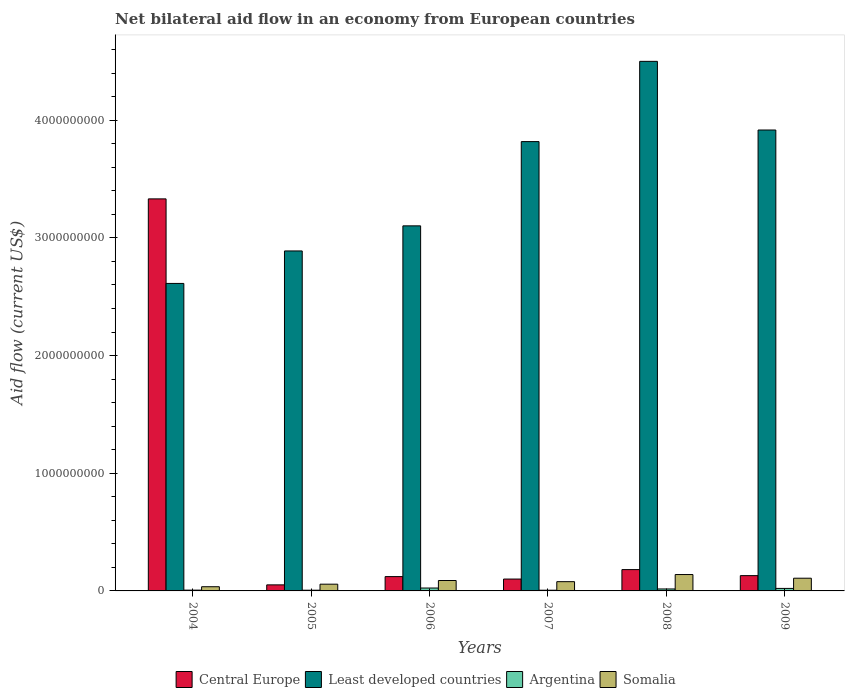How many different coloured bars are there?
Your response must be concise. 4. How many groups of bars are there?
Your answer should be very brief. 6. Are the number of bars on each tick of the X-axis equal?
Give a very brief answer. Yes. In how many cases, is the number of bars for a given year not equal to the number of legend labels?
Provide a succinct answer. 0. What is the net bilateral aid flow in Least developed countries in 2007?
Make the answer very short. 3.82e+09. Across all years, what is the maximum net bilateral aid flow in Least developed countries?
Your answer should be very brief. 4.50e+09. Across all years, what is the minimum net bilateral aid flow in Least developed countries?
Give a very brief answer. 2.61e+09. In which year was the net bilateral aid flow in Somalia maximum?
Ensure brevity in your answer.  2008. In which year was the net bilateral aid flow in Central Europe minimum?
Your answer should be very brief. 2005. What is the total net bilateral aid flow in Central Europe in the graph?
Ensure brevity in your answer.  3.92e+09. What is the difference between the net bilateral aid flow in Argentina in 2005 and that in 2009?
Provide a succinct answer. -1.52e+07. What is the difference between the net bilateral aid flow in Somalia in 2009 and the net bilateral aid flow in Least developed countries in 2006?
Provide a succinct answer. -2.99e+09. What is the average net bilateral aid flow in Central Europe per year?
Your answer should be very brief. 6.53e+08. In the year 2006, what is the difference between the net bilateral aid flow in Argentina and net bilateral aid flow in Central Europe?
Your response must be concise. -9.71e+07. What is the ratio of the net bilateral aid flow in Somalia in 2007 to that in 2008?
Ensure brevity in your answer.  0.56. What is the difference between the highest and the second highest net bilateral aid flow in Somalia?
Your response must be concise. 3.13e+07. What is the difference between the highest and the lowest net bilateral aid flow in Somalia?
Your response must be concise. 1.04e+08. Is it the case that in every year, the sum of the net bilateral aid flow in Somalia and net bilateral aid flow in Central Europe is greater than the sum of net bilateral aid flow in Argentina and net bilateral aid flow in Least developed countries?
Give a very brief answer. No. What does the 2nd bar from the left in 2004 represents?
Ensure brevity in your answer.  Least developed countries. What does the 3rd bar from the right in 2008 represents?
Provide a short and direct response. Least developed countries. Are all the bars in the graph horizontal?
Your answer should be compact. No. What is the difference between two consecutive major ticks on the Y-axis?
Provide a succinct answer. 1.00e+09. Are the values on the major ticks of Y-axis written in scientific E-notation?
Make the answer very short. No. Where does the legend appear in the graph?
Offer a very short reply. Bottom center. What is the title of the graph?
Your answer should be compact. Net bilateral aid flow in an economy from European countries. What is the label or title of the Y-axis?
Make the answer very short. Aid flow (current US$). What is the Aid flow (current US$) of Central Europe in 2004?
Keep it short and to the point. 3.33e+09. What is the Aid flow (current US$) of Least developed countries in 2004?
Your response must be concise. 2.61e+09. What is the Aid flow (current US$) of Argentina in 2004?
Provide a short and direct response. 6.68e+06. What is the Aid flow (current US$) in Somalia in 2004?
Make the answer very short. 3.57e+07. What is the Aid flow (current US$) of Central Europe in 2005?
Provide a short and direct response. 5.14e+07. What is the Aid flow (current US$) in Least developed countries in 2005?
Your answer should be very brief. 2.89e+09. What is the Aid flow (current US$) in Argentina in 2005?
Give a very brief answer. 6.03e+06. What is the Aid flow (current US$) in Somalia in 2005?
Your answer should be compact. 5.73e+07. What is the Aid flow (current US$) in Central Europe in 2006?
Keep it short and to the point. 1.22e+08. What is the Aid flow (current US$) of Least developed countries in 2006?
Keep it short and to the point. 3.10e+09. What is the Aid flow (current US$) of Argentina in 2006?
Your response must be concise. 2.46e+07. What is the Aid flow (current US$) of Somalia in 2006?
Offer a terse response. 8.85e+07. What is the Aid flow (current US$) in Central Europe in 2007?
Offer a terse response. 1.01e+08. What is the Aid flow (current US$) of Least developed countries in 2007?
Provide a short and direct response. 3.82e+09. What is the Aid flow (current US$) of Argentina in 2007?
Offer a very short reply. 6.10e+06. What is the Aid flow (current US$) of Somalia in 2007?
Make the answer very short. 7.86e+07. What is the Aid flow (current US$) of Central Europe in 2008?
Give a very brief answer. 1.81e+08. What is the Aid flow (current US$) in Least developed countries in 2008?
Provide a short and direct response. 4.50e+09. What is the Aid flow (current US$) in Argentina in 2008?
Ensure brevity in your answer.  1.66e+07. What is the Aid flow (current US$) in Somalia in 2008?
Provide a succinct answer. 1.39e+08. What is the Aid flow (current US$) in Central Europe in 2009?
Provide a short and direct response. 1.30e+08. What is the Aid flow (current US$) of Least developed countries in 2009?
Provide a short and direct response. 3.92e+09. What is the Aid flow (current US$) of Argentina in 2009?
Give a very brief answer. 2.13e+07. What is the Aid flow (current US$) of Somalia in 2009?
Your answer should be compact. 1.08e+08. Across all years, what is the maximum Aid flow (current US$) of Central Europe?
Your response must be concise. 3.33e+09. Across all years, what is the maximum Aid flow (current US$) of Least developed countries?
Ensure brevity in your answer.  4.50e+09. Across all years, what is the maximum Aid flow (current US$) of Argentina?
Give a very brief answer. 2.46e+07. Across all years, what is the maximum Aid flow (current US$) in Somalia?
Provide a succinct answer. 1.39e+08. Across all years, what is the minimum Aid flow (current US$) in Central Europe?
Your response must be concise. 5.14e+07. Across all years, what is the minimum Aid flow (current US$) in Least developed countries?
Provide a short and direct response. 2.61e+09. Across all years, what is the minimum Aid flow (current US$) of Argentina?
Your answer should be very brief. 6.03e+06. Across all years, what is the minimum Aid flow (current US$) of Somalia?
Provide a short and direct response. 3.57e+07. What is the total Aid flow (current US$) in Central Europe in the graph?
Your answer should be very brief. 3.92e+09. What is the total Aid flow (current US$) of Least developed countries in the graph?
Your answer should be compact. 2.08e+1. What is the total Aid flow (current US$) in Argentina in the graph?
Provide a short and direct response. 8.13e+07. What is the total Aid flow (current US$) of Somalia in the graph?
Provide a succinct answer. 5.07e+08. What is the difference between the Aid flow (current US$) in Central Europe in 2004 and that in 2005?
Offer a terse response. 3.28e+09. What is the difference between the Aid flow (current US$) in Least developed countries in 2004 and that in 2005?
Your answer should be compact. -2.76e+08. What is the difference between the Aid flow (current US$) in Argentina in 2004 and that in 2005?
Provide a succinct answer. 6.50e+05. What is the difference between the Aid flow (current US$) in Somalia in 2004 and that in 2005?
Give a very brief answer. -2.16e+07. What is the difference between the Aid flow (current US$) of Central Europe in 2004 and that in 2006?
Give a very brief answer. 3.21e+09. What is the difference between the Aid flow (current US$) of Least developed countries in 2004 and that in 2006?
Offer a very short reply. -4.89e+08. What is the difference between the Aid flow (current US$) in Argentina in 2004 and that in 2006?
Provide a succinct answer. -1.79e+07. What is the difference between the Aid flow (current US$) of Somalia in 2004 and that in 2006?
Make the answer very short. -5.28e+07. What is the difference between the Aid flow (current US$) of Central Europe in 2004 and that in 2007?
Provide a short and direct response. 3.23e+09. What is the difference between the Aid flow (current US$) of Least developed countries in 2004 and that in 2007?
Your answer should be compact. -1.21e+09. What is the difference between the Aid flow (current US$) of Argentina in 2004 and that in 2007?
Provide a short and direct response. 5.80e+05. What is the difference between the Aid flow (current US$) of Somalia in 2004 and that in 2007?
Your answer should be compact. -4.29e+07. What is the difference between the Aid flow (current US$) of Central Europe in 2004 and that in 2008?
Keep it short and to the point. 3.15e+09. What is the difference between the Aid flow (current US$) in Least developed countries in 2004 and that in 2008?
Offer a terse response. -1.89e+09. What is the difference between the Aid flow (current US$) of Argentina in 2004 and that in 2008?
Offer a very short reply. -9.93e+06. What is the difference between the Aid flow (current US$) in Somalia in 2004 and that in 2008?
Offer a very short reply. -1.04e+08. What is the difference between the Aid flow (current US$) of Central Europe in 2004 and that in 2009?
Ensure brevity in your answer.  3.20e+09. What is the difference between the Aid flow (current US$) in Least developed countries in 2004 and that in 2009?
Offer a terse response. -1.30e+09. What is the difference between the Aid flow (current US$) of Argentina in 2004 and that in 2009?
Ensure brevity in your answer.  -1.46e+07. What is the difference between the Aid flow (current US$) of Somalia in 2004 and that in 2009?
Your answer should be compact. -7.23e+07. What is the difference between the Aid flow (current US$) in Central Europe in 2005 and that in 2006?
Ensure brevity in your answer.  -7.03e+07. What is the difference between the Aid flow (current US$) of Least developed countries in 2005 and that in 2006?
Your response must be concise. -2.13e+08. What is the difference between the Aid flow (current US$) in Argentina in 2005 and that in 2006?
Your answer should be very brief. -1.86e+07. What is the difference between the Aid flow (current US$) of Somalia in 2005 and that in 2006?
Your answer should be very brief. -3.12e+07. What is the difference between the Aid flow (current US$) of Central Europe in 2005 and that in 2007?
Keep it short and to the point. -4.95e+07. What is the difference between the Aid flow (current US$) in Least developed countries in 2005 and that in 2007?
Ensure brevity in your answer.  -9.29e+08. What is the difference between the Aid flow (current US$) of Argentina in 2005 and that in 2007?
Provide a succinct answer. -7.00e+04. What is the difference between the Aid flow (current US$) of Somalia in 2005 and that in 2007?
Offer a very short reply. -2.13e+07. What is the difference between the Aid flow (current US$) in Central Europe in 2005 and that in 2008?
Your answer should be very brief. -1.30e+08. What is the difference between the Aid flow (current US$) in Least developed countries in 2005 and that in 2008?
Ensure brevity in your answer.  -1.61e+09. What is the difference between the Aid flow (current US$) in Argentina in 2005 and that in 2008?
Ensure brevity in your answer.  -1.06e+07. What is the difference between the Aid flow (current US$) in Somalia in 2005 and that in 2008?
Your response must be concise. -8.20e+07. What is the difference between the Aid flow (current US$) of Central Europe in 2005 and that in 2009?
Your answer should be compact. -7.85e+07. What is the difference between the Aid flow (current US$) of Least developed countries in 2005 and that in 2009?
Offer a terse response. -1.03e+09. What is the difference between the Aid flow (current US$) of Argentina in 2005 and that in 2009?
Offer a very short reply. -1.52e+07. What is the difference between the Aid flow (current US$) of Somalia in 2005 and that in 2009?
Offer a very short reply. -5.07e+07. What is the difference between the Aid flow (current US$) in Central Europe in 2006 and that in 2007?
Your answer should be compact. 2.08e+07. What is the difference between the Aid flow (current US$) of Least developed countries in 2006 and that in 2007?
Provide a short and direct response. -7.16e+08. What is the difference between the Aid flow (current US$) in Argentina in 2006 and that in 2007?
Your answer should be compact. 1.85e+07. What is the difference between the Aid flow (current US$) of Somalia in 2006 and that in 2007?
Offer a very short reply. 9.92e+06. What is the difference between the Aid flow (current US$) of Central Europe in 2006 and that in 2008?
Your answer should be compact. -5.94e+07. What is the difference between the Aid flow (current US$) in Least developed countries in 2006 and that in 2008?
Ensure brevity in your answer.  -1.40e+09. What is the difference between the Aid flow (current US$) of Argentina in 2006 and that in 2008?
Provide a short and direct response. 7.97e+06. What is the difference between the Aid flow (current US$) in Somalia in 2006 and that in 2008?
Your answer should be very brief. -5.07e+07. What is the difference between the Aid flow (current US$) of Central Europe in 2006 and that in 2009?
Provide a succinct answer. -8.24e+06. What is the difference between the Aid flow (current US$) of Least developed countries in 2006 and that in 2009?
Your answer should be compact. -8.14e+08. What is the difference between the Aid flow (current US$) of Argentina in 2006 and that in 2009?
Keep it short and to the point. 3.30e+06. What is the difference between the Aid flow (current US$) of Somalia in 2006 and that in 2009?
Provide a short and direct response. -1.95e+07. What is the difference between the Aid flow (current US$) of Central Europe in 2007 and that in 2008?
Your answer should be compact. -8.03e+07. What is the difference between the Aid flow (current US$) in Least developed countries in 2007 and that in 2008?
Give a very brief answer. -6.82e+08. What is the difference between the Aid flow (current US$) in Argentina in 2007 and that in 2008?
Your answer should be very brief. -1.05e+07. What is the difference between the Aid flow (current US$) of Somalia in 2007 and that in 2008?
Offer a very short reply. -6.06e+07. What is the difference between the Aid flow (current US$) in Central Europe in 2007 and that in 2009?
Keep it short and to the point. -2.91e+07. What is the difference between the Aid flow (current US$) in Least developed countries in 2007 and that in 2009?
Your answer should be compact. -9.84e+07. What is the difference between the Aid flow (current US$) in Argentina in 2007 and that in 2009?
Offer a terse response. -1.52e+07. What is the difference between the Aid flow (current US$) in Somalia in 2007 and that in 2009?
Your answer should be very brief. -2.94e+07. What is the difference between the Aid flow (current US$) in Central Europe in 2008 and that in 2009?
Offer a terse response. 5.12e+07. What is the difference between the Aid flow (current US$) in Least developed countries in 2008 and that in 2009?
Ensure brevity in your answer.  5.83e+08. What is the difference between the Aid flow (current US$) in Argentina in 2008 and that in 2009?
Give a very brief answer. -4.67e+06. What is the difference between the Aid flow (current US$) of Somalia in 2008 and that in 2009?
Provide a succinct answer. 3.13e+07. What is the difference between the Aid flow (current US$) in Central Europe in 2004 and the Aid flow (current US$) in Least developed countries in 2005?
Ensure brevity in your answer.  4.42e+08. What is the difference between the Aid flow (current US$) of Central Europe in 2004 and the Aid flow (current US$) of Argentina in 2005?
Provide a short and direct response. 3.33e+09. What is the difference between the Aid flow (current US$) of Central Europe in 2004 and the Aid flow (current US$) of Somalia in 2005?
Offer a very short reply. 3.27e+09. What is the difference between the Aid flow (current US$) of Least developed countries in 2004 and the Aid flow (current US$) of Argentina in 2005?
Your response must be concise. 2.61e+09. What is the difference between the Aid flow (current US$) in Least developed countries in 2004 and the Aid flow (current US$) in Somalia in 2005?
Make the answer very short. 2.56e+09. What is the difference between the Aid flow (current US$) of Argentina in 2004 and the Aid flow (current US$) of Somalia in 2005?
Keep it short and to the point. -5.06e+07. What is the difference between the Aid flow (current US$) in Central Europe in 2004 and the Aid flow (current US$) in Least developed countries in 2006?
Your response must be concise. 2.29e+08. What is the difference between the Aid flow (current US$) of Central Europe in 2004 and the Aid flow (current US$) of Argentina in 2006?
Offer a terse response. 3.31e+09. What is the difference between the Aid flow (current US$) in Central Europe in 2004 and the Aid flow (current US$) in Somalia in 2006?
Give a very brief answer. 3.24e+09. What is the difference between the Aid flow (current US$) of Least developed countries in 2004 and the Aid flow (current US$) of Argentina in 2006?
Keep it short and to the point. 2.59e+09. What is the difference between the Aid flow (current US$) in Least developed countries in 2004 and the Aid flow (current US$) in Somalia in 2006?
Provide a short and direct response. 2.52e+09. What is the difference between the Aid flow (current US$) of Argentina in 2004 and the Aid flow (current US$) of Somalia in 2006?
Your response must be concise. -8.19e+07. What is the difference between the Aid flow (current US$) of Central Europe in 2004 and the Aid flow (current US$) of Least developed countries in 2007?
Provide a short and direct response. -4.87e+08. What is the difference between the Aid flow (current US$) of Central Europe in 2004 and the Aid flow (current US$) of Argentina in 2007?
Your answer should be compact. 3.33e+09. What is the difference between the Aid flow (current US$) in Central Europe in 2004 and the Aid flow (current US$) in Somalia in 2007?
Keep it short and to the point. 3.25e+09. What is the difference between the Aid flow (current US$) of Least developed countries in 2004 and the Aid flow (current US$) of Argentina in 2007?
Offer a very short reply. 2.61e+09. What is the difference between the Aid flow (current US$) in Least developed countries in 2004 and the Aid flow (current US$) in Somalia in 2007?
Provide a short and direct response. 2.53e+09. What is the difference between the Aid flow (current US$) of Argentina in 2004 and the Aid flow (current US$) of Somalia in 2007?
Your answer should be compact. -7.19e+07. What is the difference between the Aid flow (current US$) in Central Europe in 2004 and the Aid flow (current US$) in Least developed countries in 2008?
Make the answer very short. -1.17e+09. What is the difference between the Aid flow (current US$) in Central Europe in 2004 and the Aid flow (current US$) in Argentina in 2008?
Give a very brief answer. 3.31e+09. What is the difference between the Aid flow (current US$) in Central Europe in 2004 and the Aid flow (current US$) in Somalia in 2008?
Ensure brevity in your answer.  3.19e+09. What is the difference between the Aid flow (current US$) in Least developed countries in 2004 and the Aid flow (current US$) in Argentina in 2008?
Offer a terse response. 2.60e+09. What is the difference between the Aid flow (current US$) in Least developed countries in 2004 and the Aid flow (current US$) in Somalia in 2008?
Your answer should be very brief. 2.47e+09. What is the difference between the Aid flow (current US$) in Argentina in 2004 and the Aid flow (current US$) in Somalia in 2008?
Your answer should be compact. -1.33e+08. What is the difference between the Aid flow (current US$) in Central Europe in 2004 and the Aid flow (current US$) in Least developed countries in 2009?
Offer a very short reply. -5.85e+08. What is the difference between the Aid flow (current US$) in Central Europe in 2004 and the Aid flow (current US$) in Argentina in 2009?
Your answer should be compact. 3.31e+09. What is the difference between the Aid flow (current US$) of Central Europe in 2004 and the Aid flow (current US$) of Somalia in 2009?
Offer a very short reply. 3.22e+09. What is the difference between the Aid flow (current US$) in Least developed countries in 2004 and the Aid flow (current US$) in Argentina in 2009?
Make the answer very short. 2.59e+09. What is the difference between the Aid flow (current US$) in Least developed countries in 2004 and the Aid flow (current US$) in Somalia in 2009?
Your response must be concise. 2.50e+09. What is the difference between the Aid flow (current US$) in Argentina in 2004 and the Aid flow (current US$) in Somalia in 2009?
Provide a succinct answer. -1.01e+08. What is the difference between the Aid flow (current US$) in Central Europe in 2005 and the Aid flow (current US$) in Least developed countries in 2006?
Your answer should be very brief. -3.05e+09. What is the difference between the Aid flow (current US$) of Central Europe in 2005 and the Aid flow (current US$) of Argentina in 2006?
Your response must be concise. 2.68e+07. What is the difference between the Aid flow (current US$) of Central Europe in 2005 and the Aid flow (current US$) of Somalia in 2006?
Make the answer very short. -3.71e+07. What is the difference between the Aid flow (current US$) in Least developed countries in 2005 and the Aid flow (current US$) in Argentina in 2006?
Ensure brevity in your answer.  2.86e+09. What is the difference between the Aid flow (current US$) of Least developed countries in 2005 and the Aid flow (current US$) of Somalia in 2006?
Ensure brevity in your answer.  2.80e+09. What is the difference between the Aid flow (current US$) in Argentina in 2005 and the Aid flow (current US$) in Somalia in 2006?
Keep it short and to the point. -8.25e+07. What is the difference between the Aid flow (current US$) in Central Europe in 2005 and the Aid flow (current US$) in Least developed countries in 2007?
Ensure brevity in your answer.  -3.77e+09. What is the difference between the Aid flow (current US$) of Central Europe in 2005 and the Aid flow (current US$) of Argentina in 2007?
Offer a very short reply. 4.53e+07. What is the difference between the Aid flow (current US$) of Central Europe in 2005 and the Aid flow (current US$) of Somalia in 2007?
Your answer should be compact. -2.72e+07. What is the difference between the Aid flow (current US$) of Least developed countries in 2005 and the Aid flow (current US$) of Argentina in 2007?
Provide a succinct answer. 2.88e+09. What is the difference between the Aid flow (current US$) in Least developed countries in 2005 and the Aid flow (current US$) in Somalia in 2007?
Your answer should be very brief. 2.81e+09. What is the difference between the Aid flow (current US$) of Argentina in 2005 and the Aid flow (current US$) of Somalia in 2007?
Provide a short and direct response. -7.26e+07. What is the difference between the Aid flow (current US$) of Central Europe in 2005 and the Aid flow (current US$) of Least developed countries in 2008?
Give a very brief answer. -4.45e+09. What is the difference between the Aid flow (current US$) in Central Europe in 2005 and the Aid flow (current US$) in Argentina in 2008?
Offer a very short reply. 3.48e+07. What is the difference between the Aid flow (current US$) of Central Europe in 2005 and the Aid flow (current US$) of Somalia in 2008?
Offer a terse response. -8.78e+07. What is the difference between the Aid flow (current US$) of Least developed countries in 2005 and the Aid flow (current US$) of Argentina in 2008?
Your answer should be very brief. 2.87e+09. What is the difference between the Aid flow (current US$) of Least developed countries in 2005 and the Aid flow (current US$) of Somalia in 2008?
Offer a very short reply. 2.75e+09. What is the difference between the Aid flow (current US$) in Argentina in 2005 and the Aid flow (current US$) in Somalia in 2008?
Provide a succinct answer. -1.33e+08. What is the difference between the Aid flow (current US$) of Central Europe in 2005 and the Aid flow (current US$) of Least developed countries in 2009?
Your response must be concise. -3.87e+09. What is the difference between the Aid flow (current US$) of Central Europe in 2005 and the Aid flow (current US$) of Argentina in 2009?
Offer a terse response. 3.01e+07. What is the difference between the Aid flow (current US$) in Central Europe in 2005 and the Aid flow (current US$) in Somalia in 2009?
Offer a very short reply. -5.66e+07. What is the difference between the Aid flow (current US$) in Least developed countries in 2005 and the Aid flow (current US$) in Argentina in 2009?
Your answer should be very brief. 2.87e+09. What is the difference between the Aid flow (current US$) of Least developed countries in 2005 and the Aid flow (current US$) of Somalia in 2009?
Provide a short and direct response. 2.78e+09. What is the difference between the Aid flow (current US$) in Argentina in 2005 and the Aid flow (current US$) in Somalia in 2009?
Make the answer very short. -1.02e+08. What is the difference between the Aid flow (current US$) of Central Europe in 2006 and the Aid flow (current US$) of Least developed countries in 2007?
Make the answer very short. -3.70e+09. What is the difference between the Aid flow (current US$) of Central Europe in 2006 and the Aid flow (current US$) of Argentina in 2007?
Your answer should be compact. 1.16e+08. What is the difference between the Aid flow (current US$) in Central Europe in 2006 and the Aid flow (current US$) in Somalia in 2007?
Provide a succinct answer. 4.31e+07. What is the difference between the Aid flow (current US$) of Least developed countries in 2006 and the Aid flow (current US$) of Argentina in 2007?
Keep it short and to the point. 3.10e+09. What is the difference between the Aid flow (current US$) in Least developed countries in 2006 and the Aid flow (current US$) in Somalia in 2007?
Ensure brevity in your answer.  3.02e+09. What is the difference between the Aid flow (current US$) in Argentina in 2006 and the Aid flow (current US$) in Somalia in 2007?
Offer a very short reply. -5.40e+07. What is the difference between the Aid flow (current US$) of Central Europe in 2006 and the Aid flow (current US$) of Least developed countries in 2008?
Your answer should be very brief. -4.38e+09. What is the difference between the Aid flow (current US$) of Central Europe in 2006 and the Aid flow (current US$) of Argentina in 2008?
Provide a succinct answer. 1.05e+08. What is the difference between the Aid flow (current US$) of Central Europe in 2006 and the Aid flow (current US$) of Somalia in 2008?
Provide a short and direct response. -1.76e+07. What is the difference between the Aid flow (current US$) of Least developed countries in 2006 and the Aid flow (current US$) of Argentina in 2008?
Make the answer very short. 3.09e+09. What is the difference between the Aid flow (current US$) in Least developed countries in 2006 and the Aid flow (current US$) in Somalia in 2008?
Ensure brevity in your answer.  2.96e+09. What is the difference between the Aid flow (current US$) in Argentina in 2006 and the Aid flow (current US$) in Somalia in 2008?
Offer a very short reply. -1.15e+08. What is the difference between the Aid flow (current US$) in Central Europe in 2006 and the Aid flow (current US$) in Least developed countries in 2009?
Keep it short and to the point. -3.79e+09. What is the difference between the Aid flow (current US$) of Central Europe in 2006 and the Aid flow (current US$) of Argentina in 2009?
Make the answer very short. 1.00e+08. What is the difference between the Aid flow (current US$) in Central Europe in 2006 and the Aid flow (current US$) in Somalia in 2009?
Offer a very short reply. 1.37e+07. What is the difference between the Aid flow (current US$) in Least developed countries in 2006 and the Aid flow (current US$) in Argentina in 2009?
Your answer should be very brief. 3.08e+09. What is the difference between the Aid flow (current US$) in Least developed countries in 2006 and the Aid flow (current US$) in Somalia in 2009?
Your response must be concise. 2.99e+09. What is the difference between the Aid flow (current US$) of Argentina in 2006 and the Aid flow (current US$) of Somalia in 2009?
Keep it short and to the point. -8.34e+07. What is the difference between the Aid flow (current US$) in Central Europe in 2007 and the Aid flow (current US$) in Least developed countries in 2008?
Offer a very short reply. -4.40e+09. What is the difference between the Aid flow (current US$) of Central Europe in 2007 and the Aid flow (current US$) of Argentina in 2008?
Offer a very short reply. 8.43e+07. What is the difference between the Aid flow (current US$) of Central Europe in 2007 and the Aid flow (current US$) of Somalia in 2008?
Make the answer very short. -3.84e+07. What is the difference between the Aid flow (current US$) of Least developed countries in 2007 and the Aid flow (current US$) of Argentina in 2008?
Offer a very short reply. 3.80e+09. What is the difference between the Aid flow (current US$) of Least developed countries in 2007 and the Aid flow (current US$) of Somalia in 2008?
Your answer should be very brief. 3.68e+09. What is the difference between the Aid flow (current US$) in Argentina in 2007 and the Aid flow (current US$) in Somalia in 2008?
Make the answer very short. -1.33e+08. What is the difference between the Aid flow (current US$) of Central Europe in 2007 and the Aid flow (current US$) of Least developed countries in 2009?
Offer a terse response. -3.82e+09. What is the difference between the Aid flow (current US$) of Central Europe in 2007 and the Aid flow (current US$) of Argentina in 2009?
Provide a short and direct response. 7.96e+07. What is the difference between the Aid flow (current US$) in Central Europe in 2007 and the Aid flow (current US$) in Somalia in 2009?
Keep it short and to the point. -7.13e+06. What is the difference between the Aid flow (current US$) of Least developed countries in 2007 and the Aid flow (current US$) of Argentina in 2009?
Provide a succinct answer. 3.80e+09. What is the difference between the Aid flow (current US$) in Least developed countries in 2007 and the Aid flow (current US$) in Somalia in 2009?
Offer a very short reply. 3.71e+09. What is the difference between the Aid flow (current US$) of Argentina in 2007 and the Aid flow (current US$) of Somalia in 2009?
Offer a very short reply. -1.02e+08. What is the difference between the Aid flow (current US$) in Central Europe in 2008 and the Aid flow (current US$) in Least developed countries in 2009?
Make the answer very short. -3.74e+09. What is the difference between the Aid flow (current US$) of Central Europe in 2008 and the Aid flow (current US$) of Argentina in 2009?
Your answer should be compact. 1.60e+08. What is the difference between the Aid flow (current US$) of Central Europe in 2008 and the Aid flow (current US$) of Somalia in 2009?
Your answer should be compact. 7.31e+07. What is the difference between the Aid flow (current US$) of Least developed countries in 2008 and the Aid flow (current US$) of Argentina in 2009?
Ensure brevity in your answer.  4.48e+09. What is the difference between the Aid flow (current US$) of Least developed countries in 2008 and the Aid flow (current US$) of Somalia in 2009?
Provide a short and direct response. 4.39e+09. What is the difference between the Aid flow (current US$) of Argentina in 2008 and the Aid flow (current US$) of Somalia in 2009?
Your answer should be compact. -9.14e+07. What is the average Aid flow (current US$) in Central Europe per year?
Make the answer very short. 6.53e+08. What is the average Aid flow (current US$) of Least developed countries per year?
Offer a very short reply. 3.47e+09. What is the average Aid flow (current US$) of Argentina per year?
Your response must be concise. 1.35e+07. What is the average Aid flow (current US$) in Somalia per year?
Offer a very short reply. 8.46e+07. In the year 2004, what is the difference between the Aid flow (current US$) of Central Europe and Aid flow (current US$) of Least developed countries?
Keep it short and to the point. 7.18e+08. In the year 2004, what is the difference between the Aid flow (current US$) of Central Europe and Aid flow (current US$) of Argentina?
Offer a terse response. 3.32e+09. In the year 2004, what is the difference between the Aid flow (current US$) of Central Europe and Aid flow (current US$) of Somalia?
Your response must be concise. 3.30e+09. In the year 2004, what is the difference between the Aid flow (current US$) in Least developed countries and Aid flow (current US$) in Argentina?
Offer a terse response. 2.61e+09. In the year 2004, what is the difference between the Aid flow (current US$) of Least developed countries and Aid flow (current US$) of Somalia?
Your response must be concise. 2.58e+09. In the year 2004, what is the difference between the Aid flow (current US$) of Argentina and Aid flow (current US$) of Somalia?
Provide a short and direct response. -2.90e+07. In the year 2005, what is the difference between the Aid flow (current US$) of Central Europe and Aid flow (current US$) of Least developed countries?
Your answer should be compact. -2.84e+09. In the year 2005, what is the difference between the Aid flow (current US$) in Central Europe and Aid flow (current US$) in Argentina?
Make the answer very short. 4.54e+07. In the year 2005, what is the difference between the Aid flow (current US$) in Central Europe and Aid flow (current US$) in Somalia?
Make the answer very short. -5.88e+06. In the year 2005, what is the difference between the Aid flow (current US$) in Least developed countries and Aid flow (current US$) in Argentina?
Your answer should be very brief. 2.88e+09. In the year 2005, what is the difference between the Aid flow (current US$) of Least developed countries and Aid flow (current US$) of Somalia?
Your response must be concise. 2.83e+09. In the year 2005, what is the difference between the Aid flow (current US$) in Argentina and Aid flow (current US$) in Somalia?
Offer a terse response. -5.13e+07. In the year 2006, what is the difference between the Aid flow (current US$) in Central Europe and Aid flow (current US$) in Least developed countries?
Give a very brief answer. -2.98e+09. In the year 2006, what is the difference between the Aid flow (current US$) in Central Europe and Aid flow (current US$) in Argentina?
Keep it short and to the point. 9.71e+07. In the year 2006, what is the difference between the Aid flow (current US$) in Central Europe and Aid flow (current US$) in Somalia?
Give a very brief answer. 3.32e+07. In the year 2006, what is the difference between the Aid flow (current US$) of Least developed countries and Aid flow (current US$) of Argentina?
Your response must be concise. 3.08e+09. In the year 2006, what is the difference between the Aid flow (current US$) in Least developed countries and Aid flow (current US$) in Somalia?
Provide a succinct answer. 3.01e+09. In the year 2006, what is the difference between the Aid flow (current US$) in Argentina and Aid flow (current US$) in Somalia?
Your answer should be very brief. -6.40e+07. In the year 2007, what is the difference between the Aid flow (current US$) of Central Europe and Aid flow (current US$) of Least developed countries?
Keep it short and to the point. -3.72e+09. In the year 2007, what is the difference between the Aid flow (current US$) of Central Europe and Aid flow (current US$) of Argentina?
Provide a short and direct response. 9.48e+07. In the year 2007, what is the difference between the Aid flow (current US$) of Central Europe and Aid flow (current US$) of Somalia?
Provide a short and direct response. 2.22e+07. In the year 2007, what is the difference between the Aid flow (current US$) in Least developed countries and Aid flow (current US$) in Argentina?
Offer a terse response. 3.81e+09. In the year 2007, what is the difference between the Aid flow (current US$) in Least developed countries and Aid flow (current US$) in Somalia?
Ensure brevity in your answer.  3.74e+09. In the year 2007, what is the difference between the Aid flow (current US$) in Argentina and Aid flow (current US$) in Somalia?
Your response must be concise. -7.25e+07. In the year 2008, what is the difference between the Aid flow (current US$) of Central Europe and Aid flow (current US$) of Least developed countries?
Provide a succinct answer. -4.32e+09. In the year 2008, what is the difference between the Aid flow (current US$) in Central Europe and Aid flow (current US$) in Argentina?
Provide a short and direct response. 1.65e+08. In the year 2008, what is the difference between the Aid flow (current US$) in Central Europe and Aid flow (current US$) in Somalia?
Make the answer very short. 4.19e+07. In the year 2008, what is the difference between the Aid flow (current US$) in Least developed countries and Aid flow (current US$) in Argentina?
Provide a succinct answer. 4.48e+09. In the year 2008, what is the difference between the Aid flow (current US$) of Least developed countries and Aid flow (current US$) of Somalia?
Your response must be concise. 4.36e+09. In the year 2008, what is the difference between the Aid flow (current US$) in Argentina and Aid flow (current US$) in Somalia?
Your answer should be compact. -1.23e+08. In the year 2009, what is the difference between the Aid flow (current US$) in Central Europe and Aid flow (current US$) in Least developed countries?
Give a very brief answer. -3.79e+09. In the year 2009, what is the difference between the Aid flow (current US$) in Central Europe and Aid flow (current US$) in Argentina?
Offer a very short reply. 1.09e+08. In the year 2009, what is the difference between the Aid flow (current US$) in Central Europe and Aid flow (current US$) in Somalia?
Offer a very short reply. 2.19e+07. In the year 2009, what is the difference between the Aid flow (current US$) in Least developed countries and Aid flow (current US$) in Argentina?
Ensure brevity in your answer.  3.90e+09. In the year 2009, what is the difference between the Aid flow (current US$) of Least developed countries and Aid flow (current US$) of Somalia?
Offer a terse response. 3.81e+09. In the year 2009, what is the difference between the Aid flow (current US$) of Argentina and Aid flow (current US$) of Somalia?
Ensure brevity in your answer.  -8.67e+07. What is the ratio of the Aid flow (current US$) of Central Europe in 2004 to that in 2005?
Ensure brevity in your answer.  64.8. What is the ratio of the Aid flow (current US$) in Least developed countries in 2004 to that in 2005?
Your answer should be compact. 0.9. What is the ratio of the Aid flow (current US$) in Argentina in 2004 to that in 2005?
Make the answer very short. 1.11. What is the ratio of the Aid flow (current US$) of Somalia in 2004 to that in 2005?
Make the answer very short. 0.62. What is the ratio of the Aid flow (current US$) of Central Europe in 2004 to that in 2006?
Your answer should be very brief. 27.37. What is the ratio of the Aid flow (current US$) in Least developed countries in 2004 to that in 2006?
Make the answer very short. 0.84. What is the ratio of the Aid flow (current US$) of Argentina in 2004 to that in 2006?
Offer a terse response. 0.27. What is the ratio of the Aid flow (current US$) in Somalia in 2004 to that in 2006?
Provide a short and direct response. 0.4. What is the ratio of the Aid flow (current US$) in Central Europe in 2004 to that in 2007?
Ensure brevity in your answer.  33.03. What is the ratio of the Aid flow (current US$) in Least developed countries in 2004 to that in 2007?
Your answer should be very brief. 0.68. What is the ratio of the Aid flow (current US$) of Argentina in 2004 to that in 2007?
Keep it short and to the point. 1.1. What is the ratio of the Aid flow (current US$) in Somalia in 2004 to that in 2007?
Your response must be concise. 0.45. What is the ratio of the Aid flow (current US$) of Central Europe in 2004 to that in 2008?
Your answer should be compact. 18.39. What is the ratio of the Aid flow (current US$) of Least developed countries in 2004 to that in 2008?
Offer a terse response. 0.58. What is the ratio of the Aid flow (current US$) in Argentina in 2004 to that in 2008?
Ensure brevity in your answer.  0.4. What is the ratio of the Aid flow (current US$) of Somalia in 2004 to that in 2008?
Provide a succinct answer. 0.26. What is the ratio of the Aid flow (current US$) of Central Europe in 2004 to that in 2009?
Offer a terse response. 25.64. What is the ratio of the Aid flow (current US$) of Least developed countries in 2004 to that in 2009?
Your answer should be compact. 0.67. What is the ratio of the Aid flow (current US$) in Argentina in 2004 to that in 2009?
Your answer should be very brief. 0.31. What is the ratio of the Aid flow (current US$) of Somalia in 2004 to that in 2009?
Provide a succinct answer. 0.33. What is the ratio of the Aid flow (current US$) in Central Europe in 2005 to that in 2006?
Offer a very short reply. 0.42. What is the ratio of the Aid flow (current US$) in Least developed countries in 2005 to that in 2006?
Keep it short and to the point. 0.93. What is the ratio of the Aid flow (current US$) of Argentina in 2005 to that in 2006?
Provide a short and direct response. 0.25. What is the ratio of the Aid flow (current US$) of Somalia in 2005 to that in 2006?
Provide a succinct answer. 0.65. What is the ratio of the Aid flow (current US$) in Central Europe in 2005 to that in 2007?
Your response must be concise. 0.51. What is the ratio of the Aid flow (current US$) of Least developed countries in 2005 to that in 2007?
Keep it short and to the point. 0.76. What is the ratio of the Aid flow (current US$) of Argentina in 2005 to that in 2007?
Your answer should be compact. 0.99. What is the ratio of the Aid flow (current US$) of Somalia in 2005 to that in 2007?
Make the answer very short. 0.73. What is the ratio of the Aid flow (current US$) of Central Europe in 2005 to that in 2008?
Provide a succinct answer. 0.28. What is the ratio of the Aid flow (current US$) of Least developed countries in 2005 to that in 2008?
Provide a succinct answer. 0.64. What is the ratio of the Aid flow (current US$) in Argentina in 2005 to that in 2008?
Your answer should be compact. 0.36. What is the ratio of the Aid flow (current US$) in Somalia in 2005 to that in 2008?
Give a very brief answer. 0.41. What is the ratio of the Aid flow (current US$) of Central Europe in 2005 to that in 2009?
Make the answer very short. 0.4. What is the ratio of the Aid flow (current US$) of Least developed countries in 2005 to that in 2009?
Make the answer very short. 0.74. What is the ratio of the Aid flow (current US$) in Argentina in 2005 to that in 2009?
Your answer should be compact. 0.28. What is the ratio of the Aid flow (current US$) in Somalia in 2005 to that in 2009?
Provide a succinct answer. 0.53. What is the ratio of the Aid flow (current US$) of Central Europe in 2006 to that in 2007?
Make the answer very short. 1.21. What is the ratio of the Aid flow (current US$) in Least developed countries in 2006 to that in 2007?
Provide a short and direct response. 0.81. What is the ratio of the Aid flow (current US$) of Argentina in 2006 to that in 2007?
Ensure brevity in your answer.  4.03. What is the ratio of the Aid flow (current US$) of Somalia in 2006 to that in 2007?
Ensure brevity in your answer.  1.13. What is the ratio of the Aid flow (current US$) in Central Europe in 2006 to that in 2008?
Your answer should be very brief. 0.67. What is the ratio of the Aid flow (current US$) of Least developed countries in 2006 to that in 2008?
Offer a terse response. 0.69. What is the ratio of the Aid flow (current US$) in Argentina in 2006 to that in 2008?
Offer a very short reply. 1.48. What is the ratio of the Aid flow (current US$) of Somalia in 2006 to that in 2008?
Your response must be concise. 0.64. What is the ratio of the Aid flow (current US$) in Central Europe in 2006 to that in 2009?
Offer a very short reply. 0.94. What is the ratio of the Aid flow (current US$) in Least developed countries in 2006 to that in 2009?
Keep it short and to the point. 0.79. What is the ratio of the Aid flow (current US$) of Argentina in 2006 to that in 2009?
Give a very brief answer. 1.16. What is the ratio of the Aid flow (current US$) in Somalia in 2006 to that in 2009?
Offer a very short reply. 0.82. What is the ratio of the Aid flow (current US$) in Central Europe in 2007 to that in 2008?
Provide a succinct answer. 0.56. What is the ratio of the Aid flow (current US$) in Least developed countries in 2007 to that in 2008?
Your answer should be compact. 0.85. What is the ratio of the Aid flow (current US$) in Argentina in 2007 to that in 2008?
Offer a terse response. 0.37. What is the ratio of the Aid flow (current US$) in Somalia in 2007 to that in 2008?
Your answer should be compact. 0.56. What is the ratio of the Aid flow (current US$) of Central Europe in 2007 to that in 2009?
Offer a terse response. 0.78. What is the ratio of the Aid flow (current US$) of Least developed countries in 2007 to that in 2009?
Offer a very short reply. 0.97. What is the ratio of the Aid flow (current US$) of Argentina in 2007 to that in 2009?
Provide a succinct answer. 0.29. What is the ratio of the Aid flow (current US$) of Somalia in 2007 to that in 2009?
Offer a terse response. 0.73. What is the ratio of the Aid flow (current US$) of Central Europe in 2008 to that in 2009?
Offer a very short reply. 1.39. What is the ratio of the Aid flow (current US$) in Least developed countries in 2008 to that in 2009?
Ensure brevity in your answer.  1.15. What is the ratio of the Aid flow (current US$) in Argentina in 2008 to that in 2009?
Your answer should be very brief. 0.78. What is the ratio of the Aid flow (current US$) of Somalia in 2008 to that in 2009?
Offer a terse response. 1.29. What is the difference between the highest and the second highest Aid flow (current US$) in Central Europe?
Your answer should be very brief. 3.15e+09. What is the difference between the highest and the second highest Aid flow (current US$) of Least developed countries?
Offer a very short reply. 5.83e+08. What is the difference between the highest and the second highest Aid flow (current US$) in Argentina?
Offer a terse response. 3.30e+06. What is the difference between the highest and the second highest Aid flow (current US$) of Somalia?
Make the answer very short. 3.13e+07. What is the difference between the highest and the lowest Aid flow (current US$) in Central Europe?
Provide a succinct answer. 3.28e+09. What is the difference between the highest and the lowest Aid flow (current US$) in Least developed countries?
Provide a short and direct response. 1.89e+09. What is the difference between the highest and the lowest Aid flow (current US$) in Argentina?
Provide a succinct answer. 1.86e+07. What is the difference between the highest and the lowest Aid flow (current US$) of Somalia?
Give a very brief answer. 1.04e+08. 